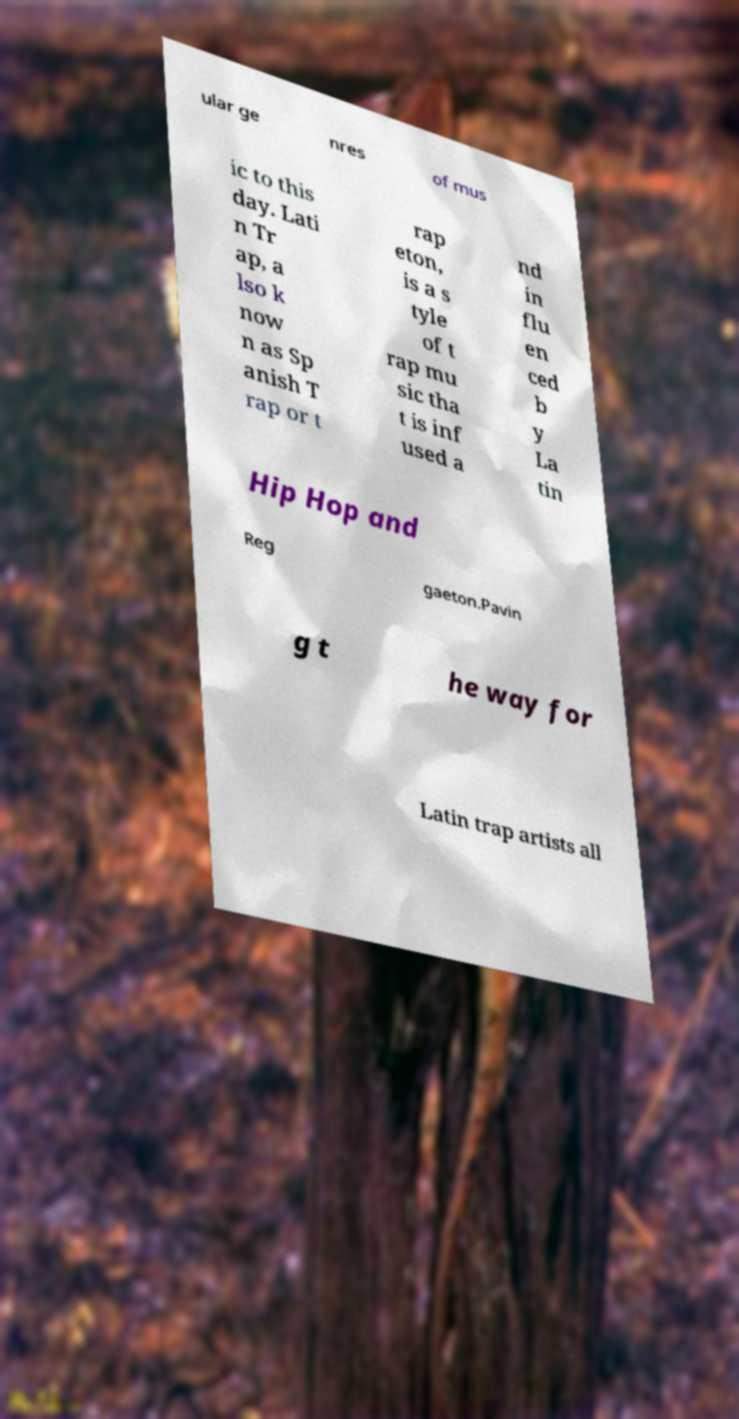Please identify and transcribe the text found in this image. ular ge nres of mus ic to this day. Lati n Tr ap, a lso k now n as Sp anish T rap or t rap eton, is a s tyle of t rap mu sic tha t is inf used a nd in flu en ced b y La tin Hip Hop and Reg gaeton.Pavin g t he way for Latin trap artists all 